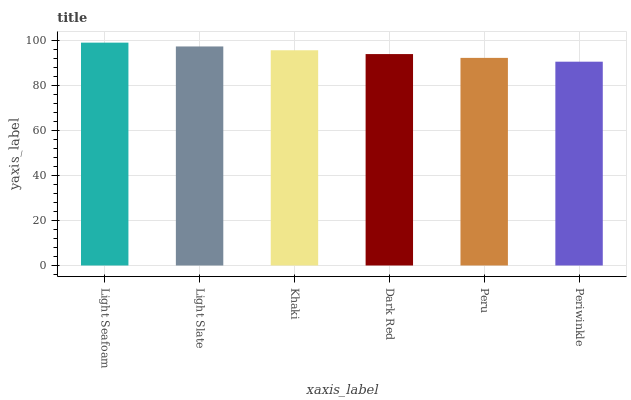Is Periwinkle the minimum?
Answer yes or no. Yes. Is Light Seafoam the maximum?
Answer yes or no. Yes. Is Light Slate the minimum?
Answer yes or no. No. Is Light Slate the maximum?
Answer yes or no. No. Is Light Seafoam greater than Light Slate?
Answer yes or no. Yes. Is Light Slate less than Light Seafoam?
Answer yes or no. Yes. Is Light Slate greater than Light Seafoam?
Answer yes or no. No. Is Light Seafoam less than Light Slate?
Answer yes or no. No. Is Khaki the high median?
Answer yes or no. Yes. Is Dark Red the low median?
Answer yes or no. Yes. Is Periwinkle the high median?
Answer yes or no. No. Is Periwinkle the low median?
Answer yes or no. No. 